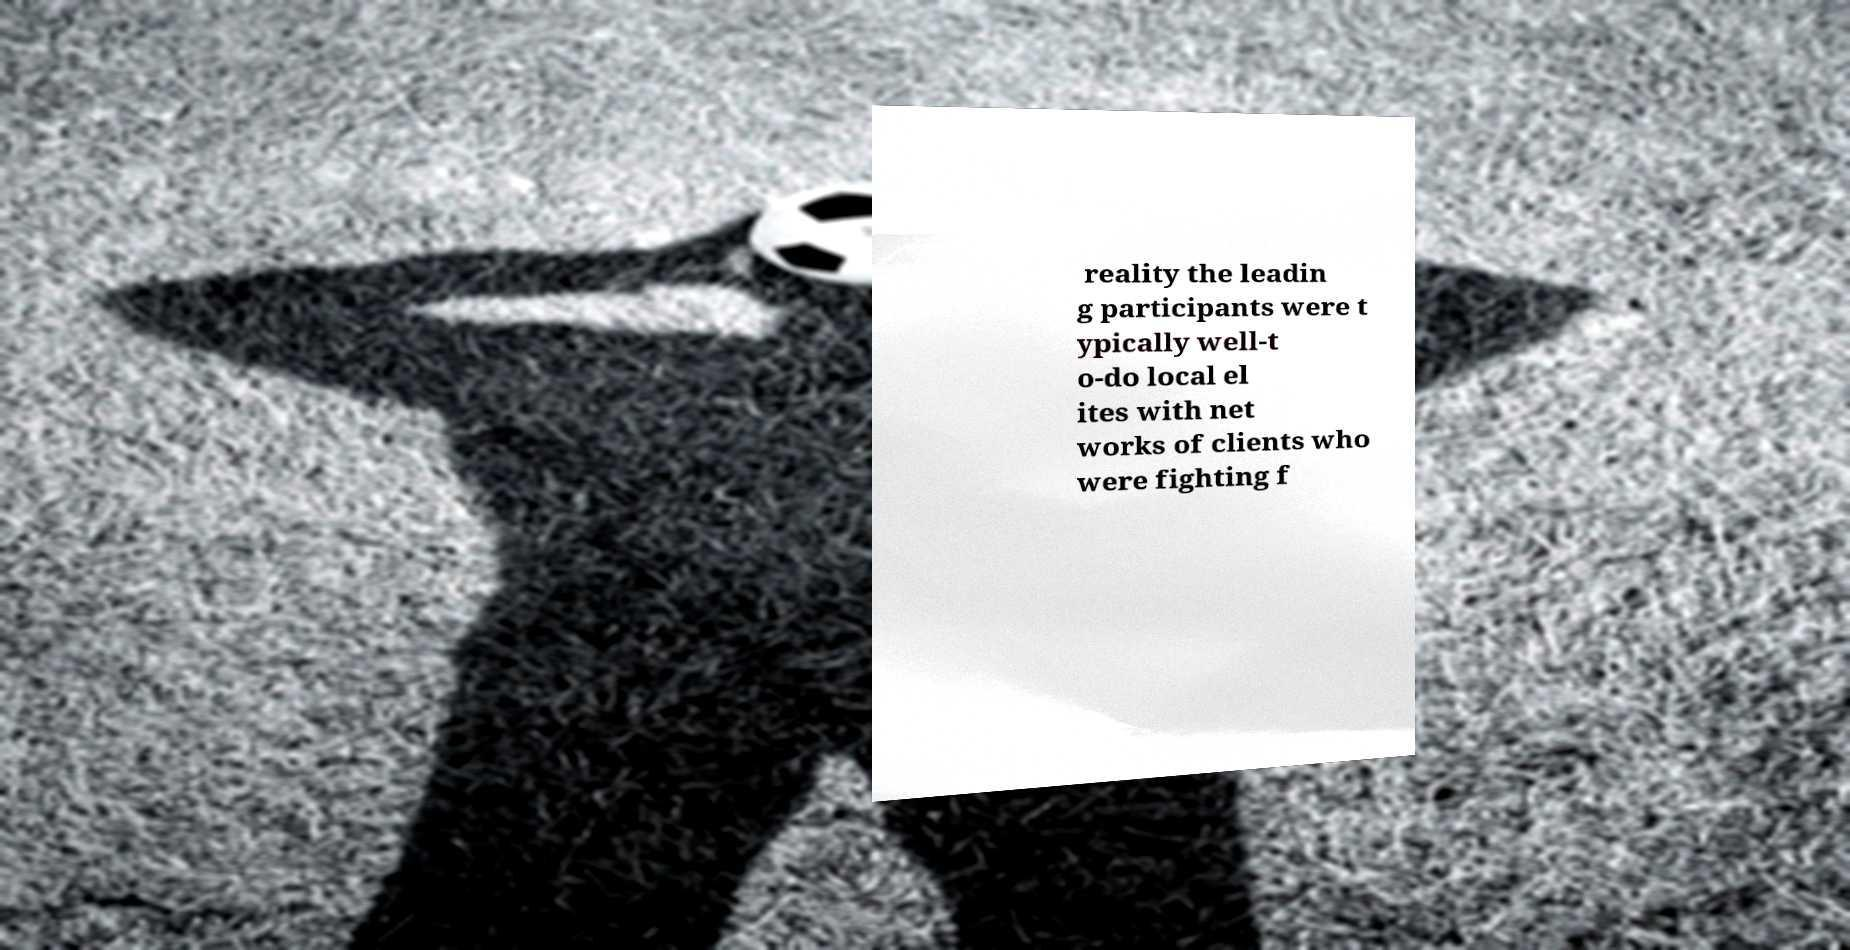Can you read and provide the text displayed in the image?This photo seems to have some interesting text. Can you extract and type it out for me? reality the leadin g participants were t ypically well-t o-do local el ites with net works of clients who were fighting f 